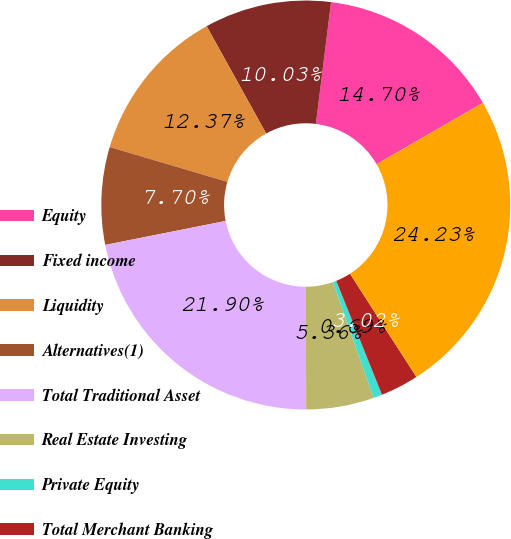Convert chart. <chart><loc_0><loc_0><loc_500><loc_500><pie_chart><fcel>Equity<fcel>Fixed income<fcel>Liquidity<fcel>Alternatives(1)<fcel>Total Traditional Asset<fcel>Real Estate Investing<fcel>Private Equity<fcel>Total Merchant Banking<fcel>Total assets under management<nl><fcel>14.7%<fcel>10.03%<fcel>12.37%<fcel>7.7%<fcel>21.9%<fcel>5.36%<fcel>0.69%<fcel>3.02%<fcel>24.23%<nl></chart> 